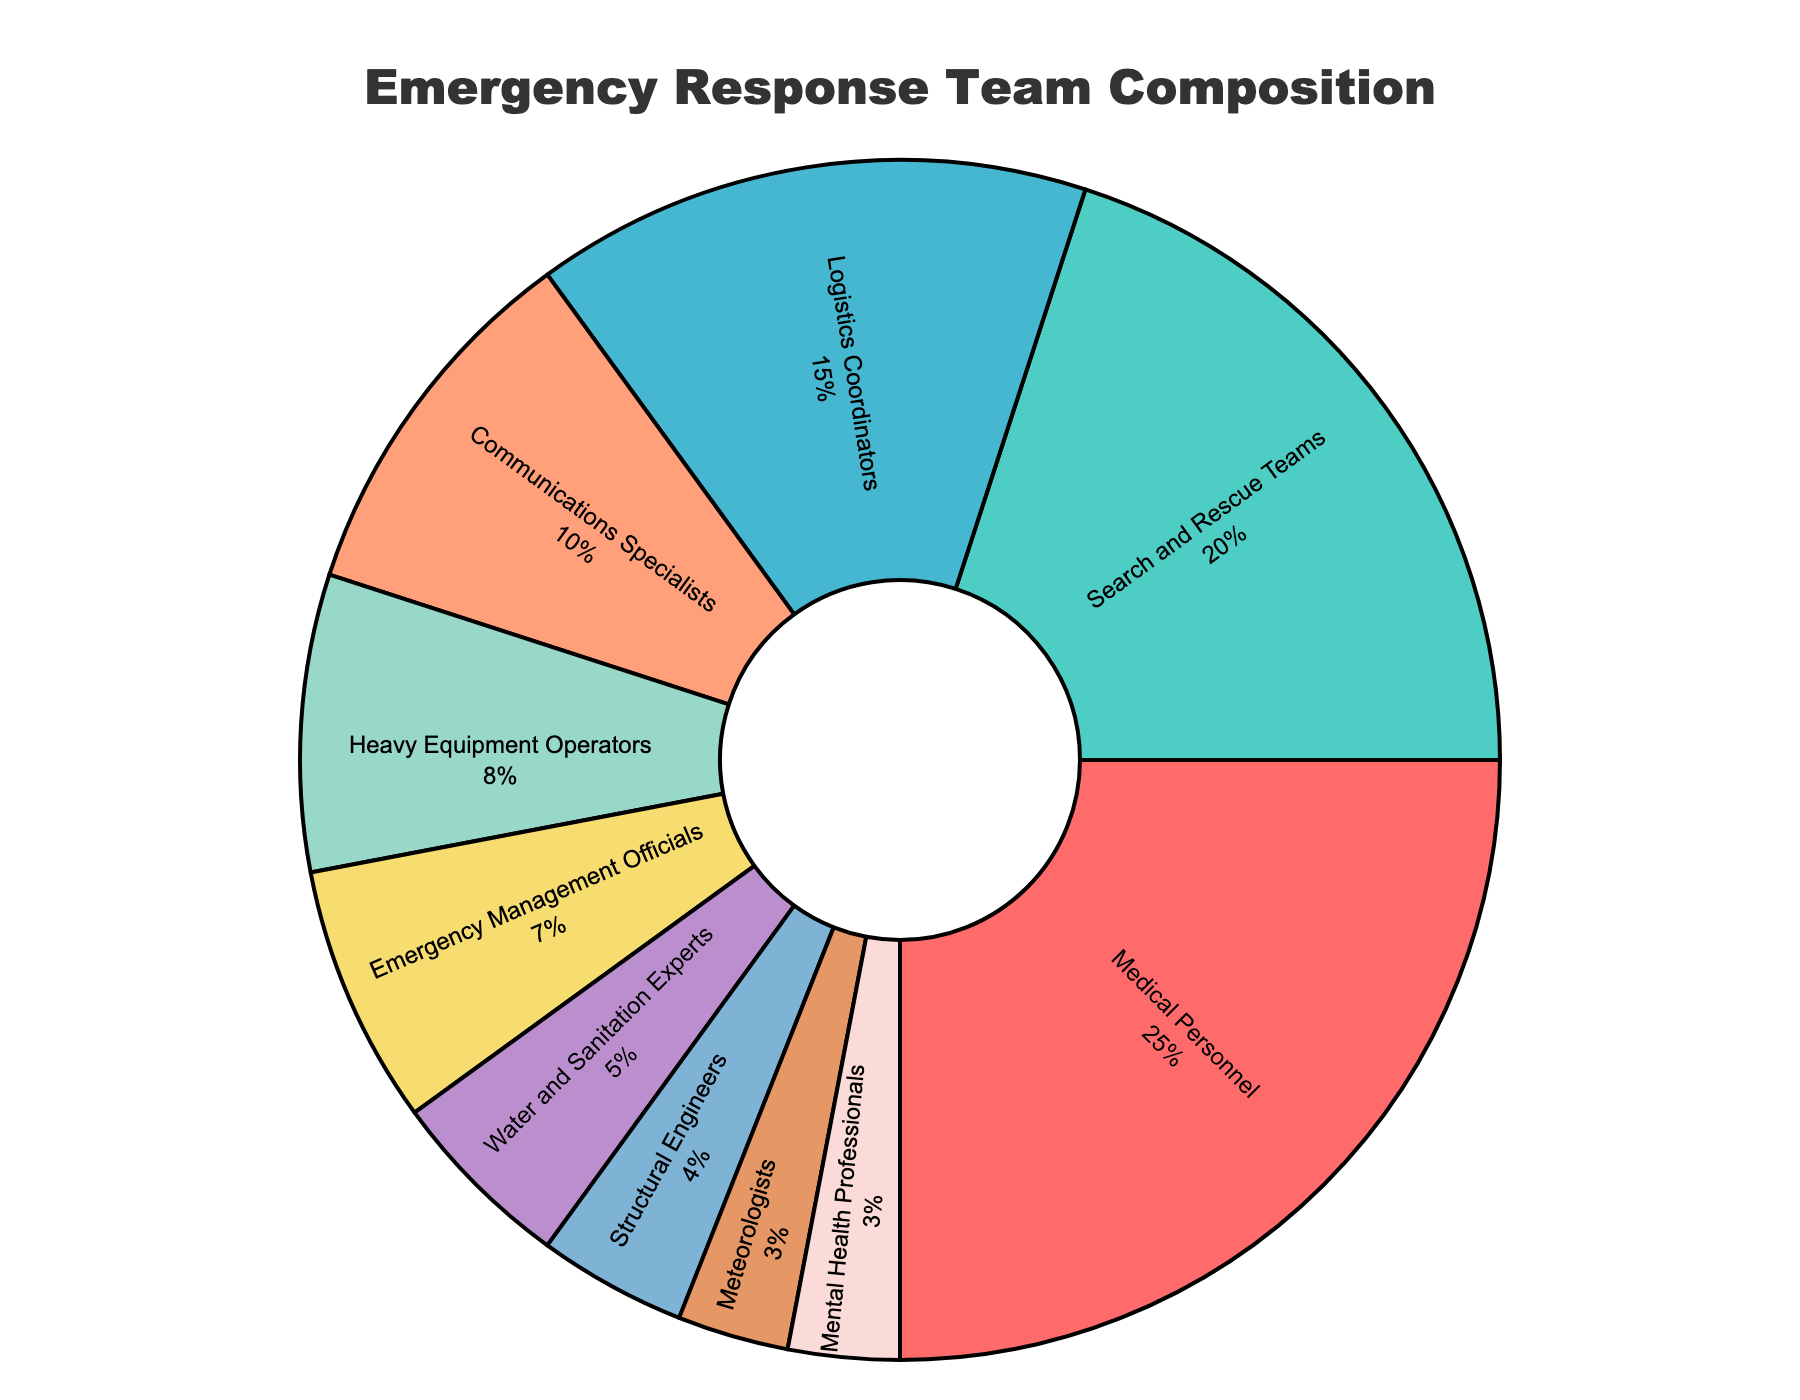Which specialization makes up the largest portion of the emergency response team? According to the chart, the largest segment is the one labeled "Medical Personnel," which comprises 25% of the total team.
Answer: Medical Personnel How much larger is the proportion of Medical Personnel than the proportion of Mental Health Professionals? Medical Personnel constitutes 25% of the team, whereas Mental Health Professionals make up 3%. The difference between them is 25% - 3% = 22%.
Answer: 22% What is the combined percentage of Search and Rescue Teams and Logistics Coordinators? Search and Rescue Teams account for 20% and Logistics Coordinators account for 15%. Adding the two percentages together gives us 20% + 15% = 35%.
Answer: 35% How do the proportions of Heavy Equipment Operators and Communications Specialists compare? Heavy Equipment Operators make up 8% of the team and Communications Specialists make up 10%. Comparing these, Communications Specialists have a larger percentage.
Answer: Communications Specialists Which specialization has the smallest representation and what percentage does it make up? The smallest segment is for Meteorologists, making up 3% of the emergency response team.
Answer: Meteorologists How do Medical Personnel and Search and Rescue Teams comprise the total percentage together? Medical Personnel are 25% and Search and Rescue Teams are 20%. Together, they comprise 25% + 20% = 45% of the team.
Answer: 45% What is the sum of the percentages for Water and Sanitation Experts, Structural Engineers, and Meteorologists? Water and Sanitation Experts are 5%, Structural Engineers are 4%, and Meteorologists are 3%. Adding them gives us 5% + 4% + 3% = 12%.
Answer: 12% Which specialization occupies the green section of the pie chart? To identify the green segment, look for the section labeled with green color. It is the Search and Rescue Teams, which is 20% of the chart.
Answer: Search and Rescue Teams 